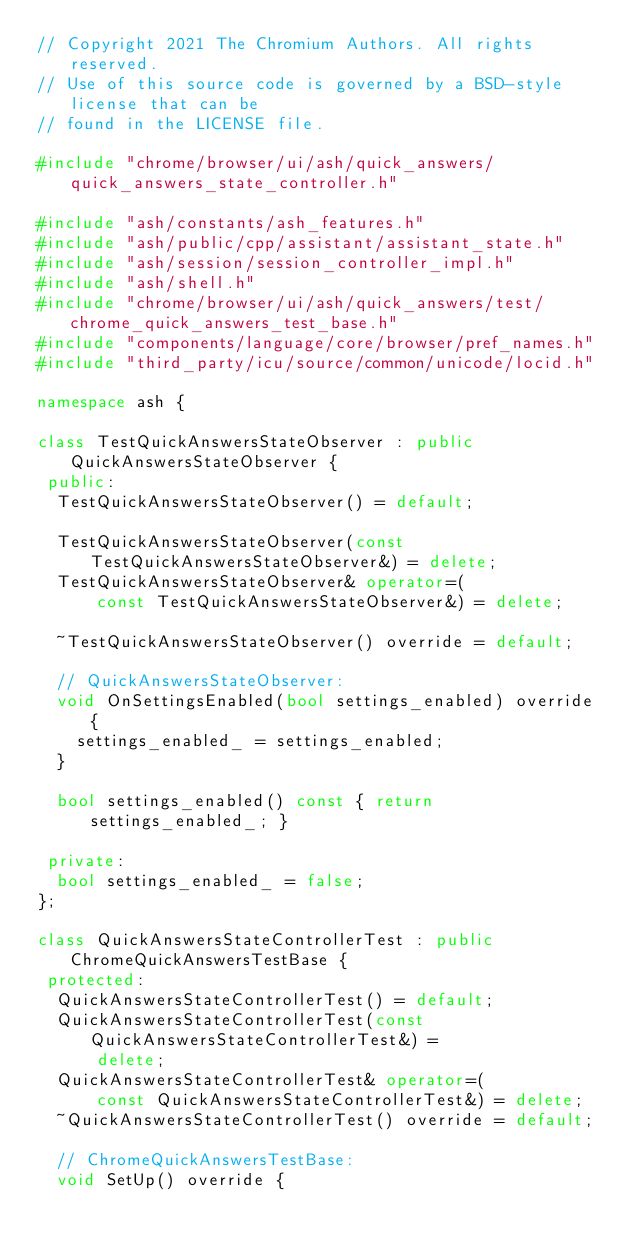<code> <loc_0><loc_0><loc_500><loc_500><_C++_>// Copyright 2021 The Chromium Authors. All rights reserved.
// Use of this source code is governed by a BSD-style license that can be
// found in the LICENSE file.

#include "chrome/browser/ui/ash/quick_answers/quick_answers_state_controller.h"

#include "ash/constants/ash_features.h"
#include "ash/public/cpp/assistant/assistant_state.h"
#include "ash/session/session_controller_impl.h"
#include "ash/shell.h"
#include "chrome/browser/ui/ash/quick_answers/test/chrome_quick_answers_test_base.h"
#include "components/language/core/browser/pref_names.h"
#include "third_party/icu/source/common/unicode/locid.h"

namespace ash {

class TestQuickAnswersStateObserver : public QuickAnswersStateObserver {
 public:
  TestQuickAnswersStateObserver() = default;

  TestQuickAnswersStateObserver(const TestQuickAnswersStateObserver&) = delete;
  TestQuickAnswersStateObserver& operator=(
      const TestQuickAnswersStateObserver&) = delete;

  ~TestQuickAnswersStateObserver() override = default;

  // QuickAnswersStateObserver:
  void OnSettingsEnabled(bool settings_enabled) override {
    settings_enabled_ = settings_enabled;
  }

  bool settings_enabled() const { return settings_enabled_; }

 private:
  bool settings_enabled_ = false;
};

class QuickAnswersStateControllerTest : public ChromeQuickAnswersTestBase {
 protected:
  QuickAnswersStateControllerTest() = default;
  QuickAnswersStateControllerTest(const QuickAnswersStateControllerTest&) =
      delete;
  QuickAnswersStateControllerTest& operator=(
      const QuickAnswersStateControllerTest&) = delete;
  ~QuickAnswersStateControllerTest() override = default;

  // ChromeQuickAnswersTestBase:
  void SetUp() override {</code> 